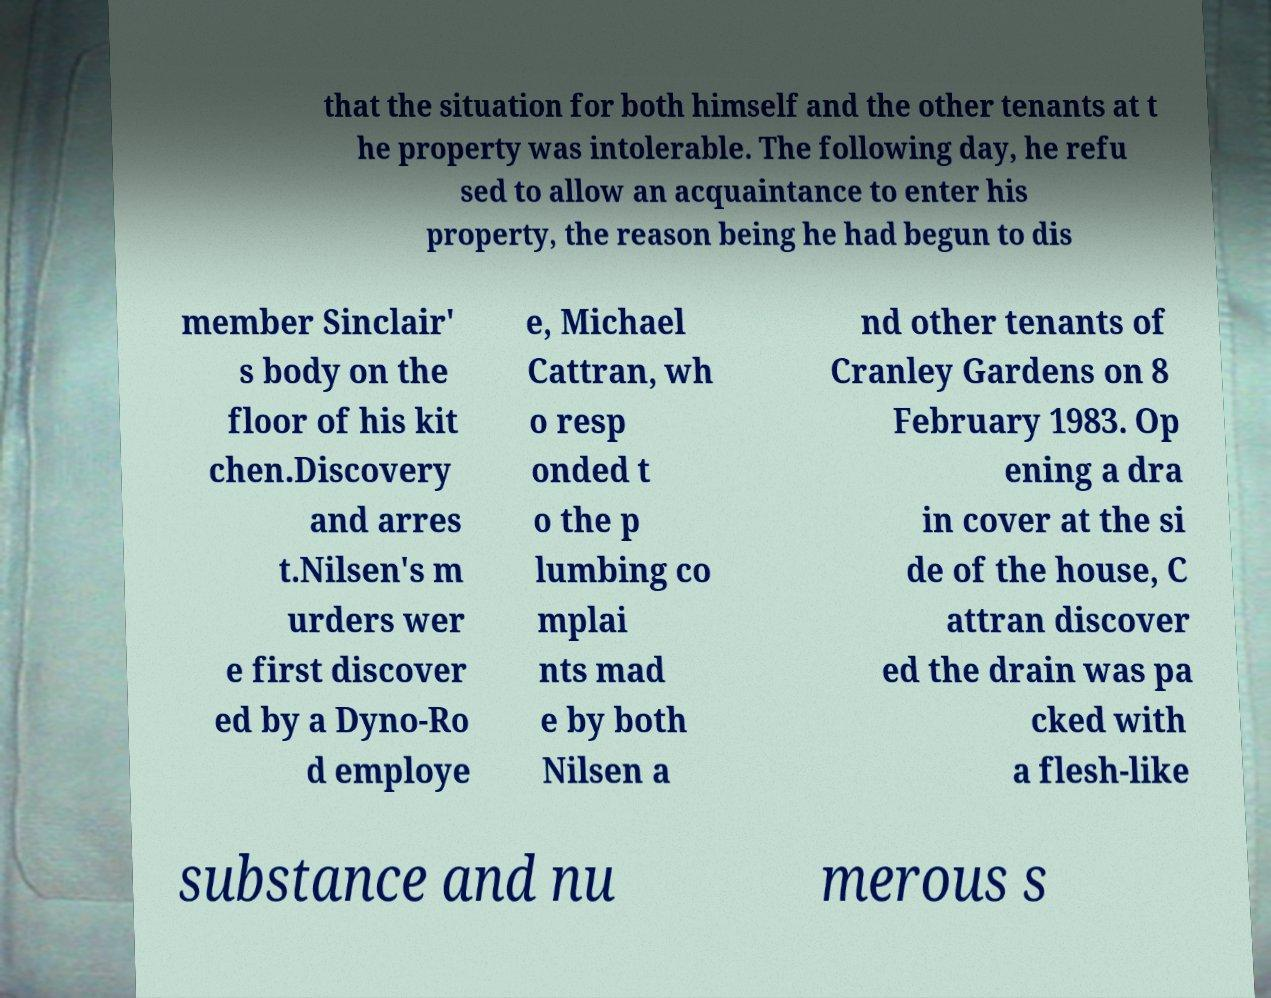Please read and relay the text visible in this image. What does it say? that the situation for both himself and the other tenants at t he property was intolerable. The following day, he refu sed to allow an acquaintance to enter his property, the reason being he had begun to dis member Sinclair' s body on the floor of his kit chen.Discovery and arres t.Nilsen's m urders wer e first discover ed by a Dyno-Ro d employe e, Michael Cattran, wh o resp onded t o the p lumbing co mplai nts mad e by both Nilsen a nd other tenants of Cranley Gardens on 8 February 1983. Op ening a dra in cover at the si de of the house, C attran discover ed the drain was pa cked with a flesh-like substance and nu merous s 